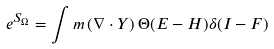<formula> <loc_0><loc_0><loc_500><loc_500>e ^ { S _ { \Omega } } = \int m \, ( \nabla \cdot Y ) \, \Theta ( E - H ) \delta ( I - F )</formula> 